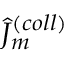<formula> <loc_0><loc_0><loc_500><loc_500>\hat { J } _ { m } ^ { ( c o l l ) }</formula> 